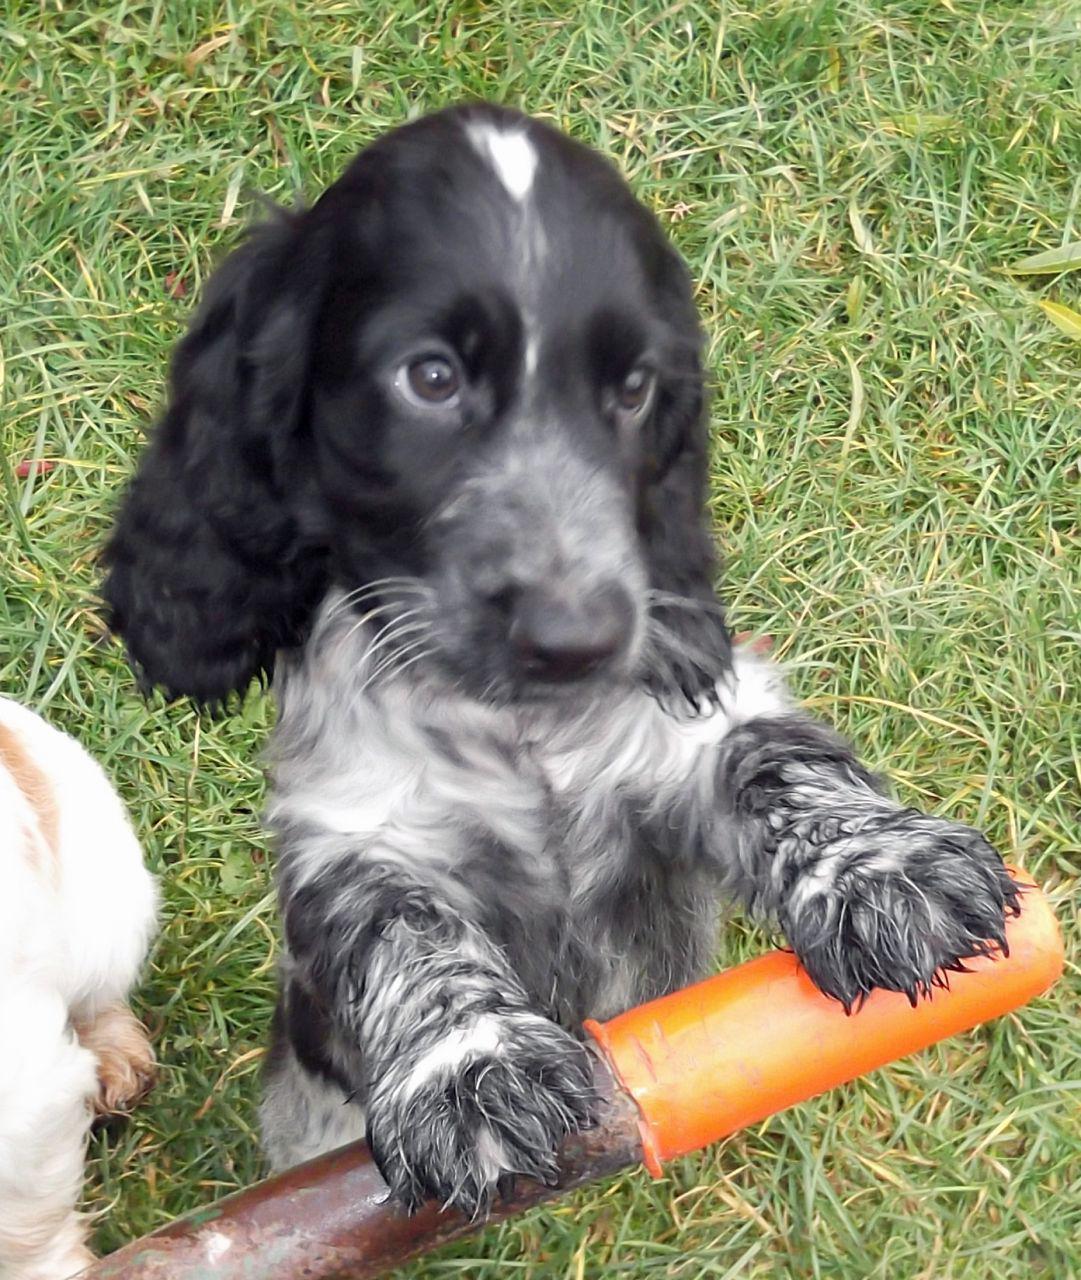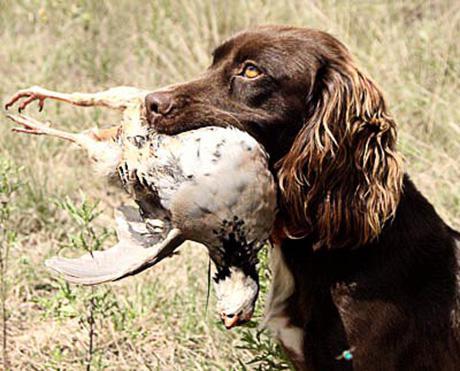The first image is the image on the left, the second image is the image on the right. Given the left and right images, does the statement "The dog in the image on the right is carrying something in it's mouth." hold true? Answer yes or no. Yes. The first image is the image on the left, the second image is the image on the right. Considering the images on both sides, is "One of the dogs is carrying something in its mouth." valid? Answer yes or no. Yes. 